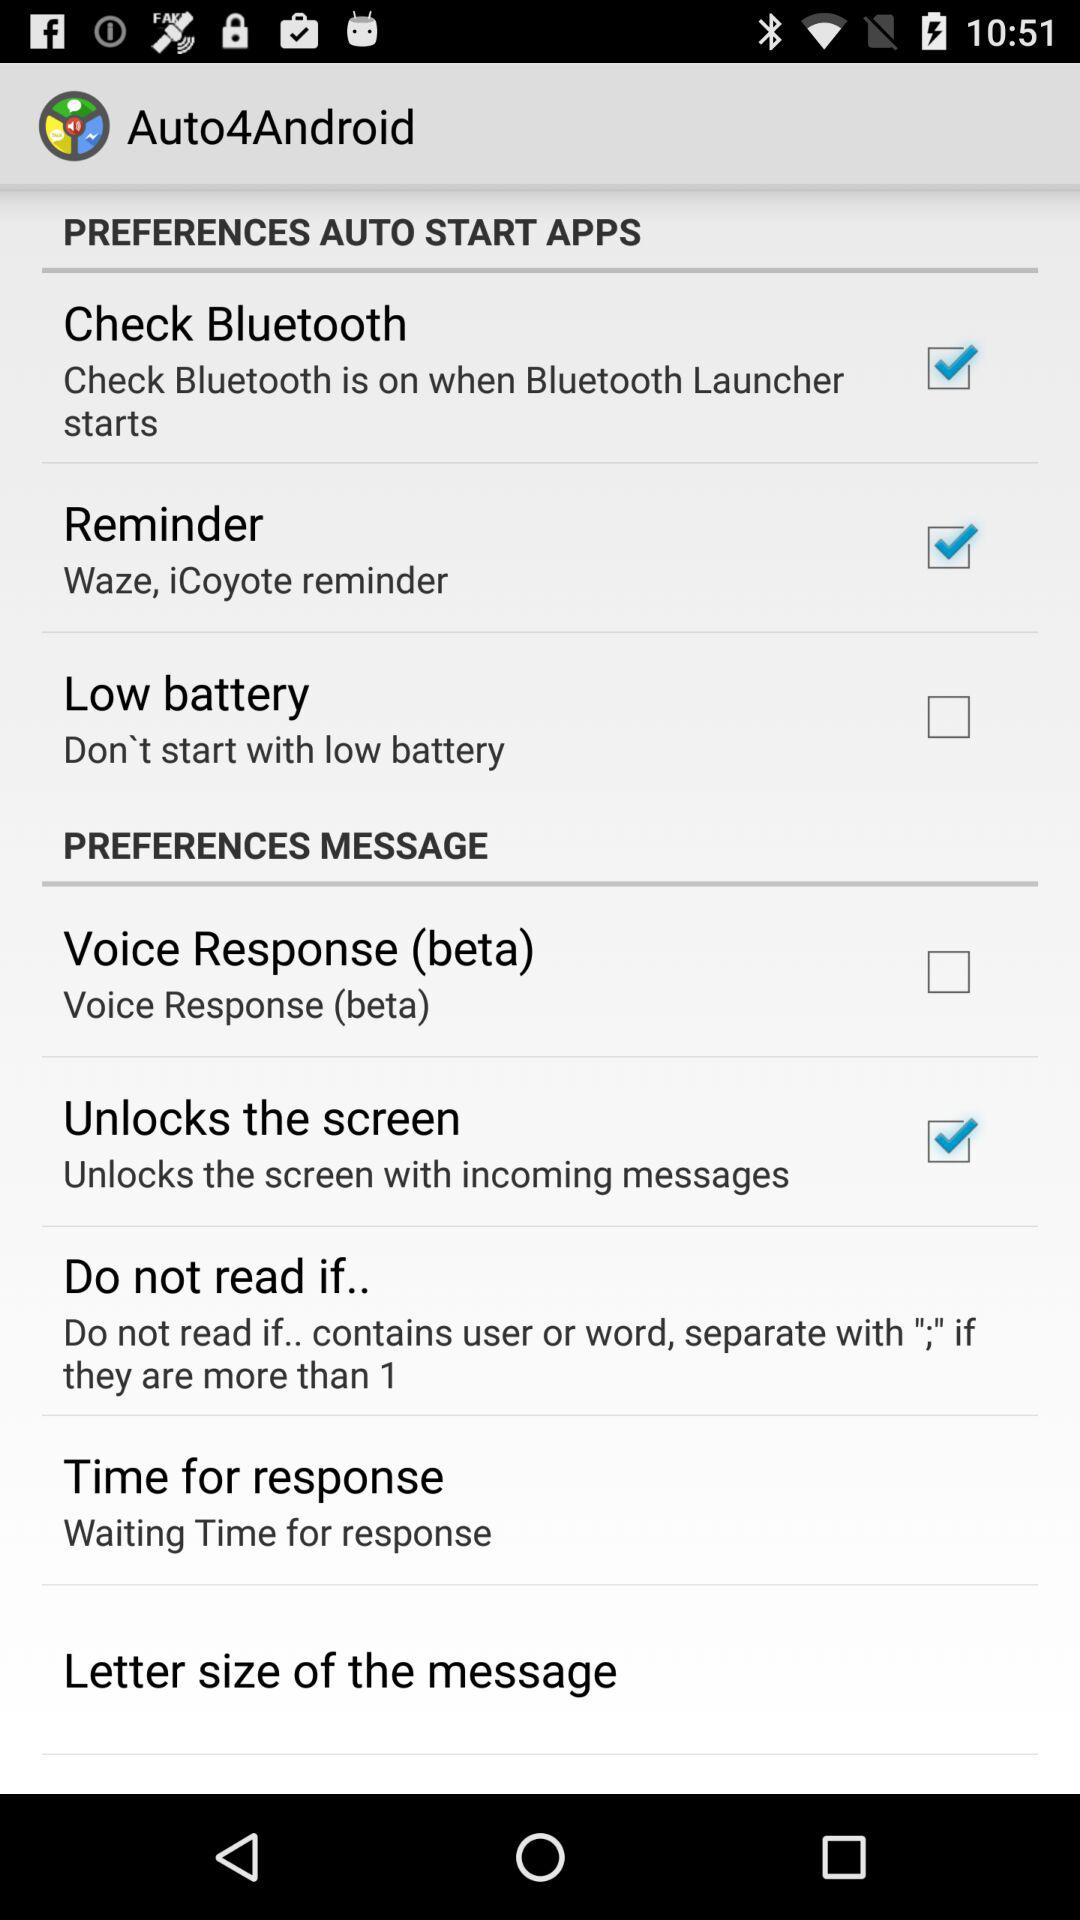What is the status of "Low battery"? The status of "Low battery" is "off". 